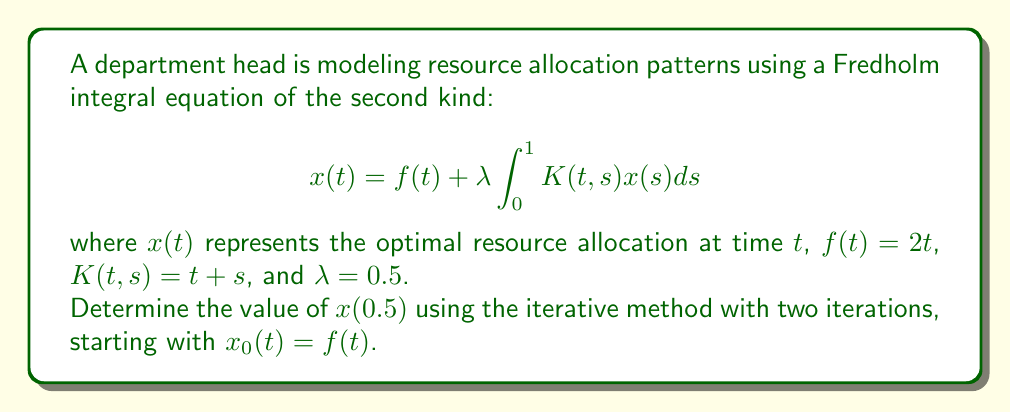Can you answer this question? To solve this problem, we'll use the iterative method for Fredholm integral equations:

1) Start with $x_0(t) = f(t) = 2t$

2) For the first iteration:
   $$x_1(t) = f(t) + \lambda \int_0^1 K(t,s)x_0(s)ds$$
   $$x_1(t) = 2t + 0.5 \int_0^1 (t+s)(2s)ds$$
   $$x_1(t) = 2t + 0.5 \left[2ts + s^2\right]_0^1$$
   $$x_1(t) = 2t + 0.5(2t + 1) = 2t + t + 0.5 = t + 2.5$$

3) For the second iteration:
   $$x_2(t) = f(t) + \lambda \int_0^1 K(t,s)x_1(s)ds$$
   $$x_2(t) = 2t + 0.5 \int_0^1 (t+s)(s + 2.5)ds$$
   $$x_2(t) = 2t + 0.5 \left[ts^2 + 2.5ts + \frac{s^3}{3} + 1.25s^2\right]_0^1$$
   $$x_2(t) = 2t + 0.5(t + 2.5t + \frac{1}{3} + 1.25)$$
   $$x_2(t) = 2t + 1.75t + \frac{1}{6} + 0.625$$
   $$x_2(t) = 3.75t + 0.7916667$$

4) To find $x(0.5)$, we substitute $t = 0.5$ into $x_2(t)$:
   $$x_2(0.5) = 3.75(0.5) + 0.7916667 = 2.6666667$$
Answer: $2.6666667$ 